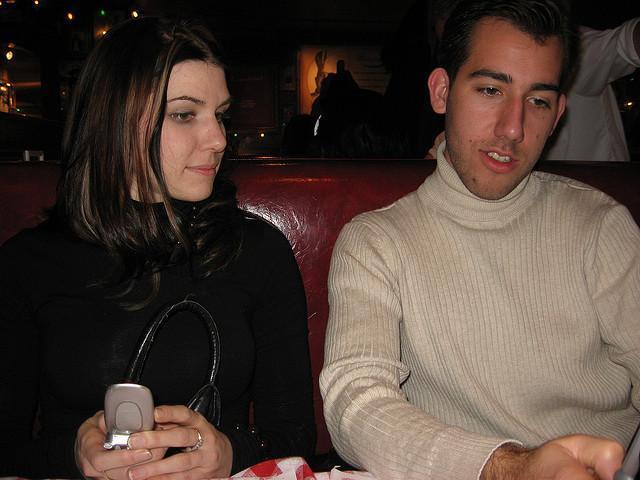How many people are in the photo?
Give a very brief answer. 3. 